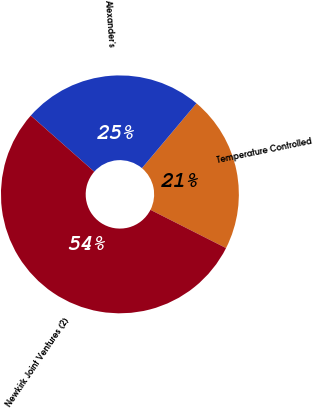<chart> <loc_0><loc_0><loc_500><loc_500><pie_chart><fcel>Temperature Controlled<fcel>Alexander's<fcel>Newkirk Joint Ventures (2)<nl><fcel>21.33%<fcel>24.61%<fcel>54.06%<nl></chart> 